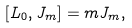Convert formula to latex. <formula><loc_0><loc_0><loc_500><loc_500>[ L _ { 0 } , J _ { m } ] = m J _ { m } ,</formula> 